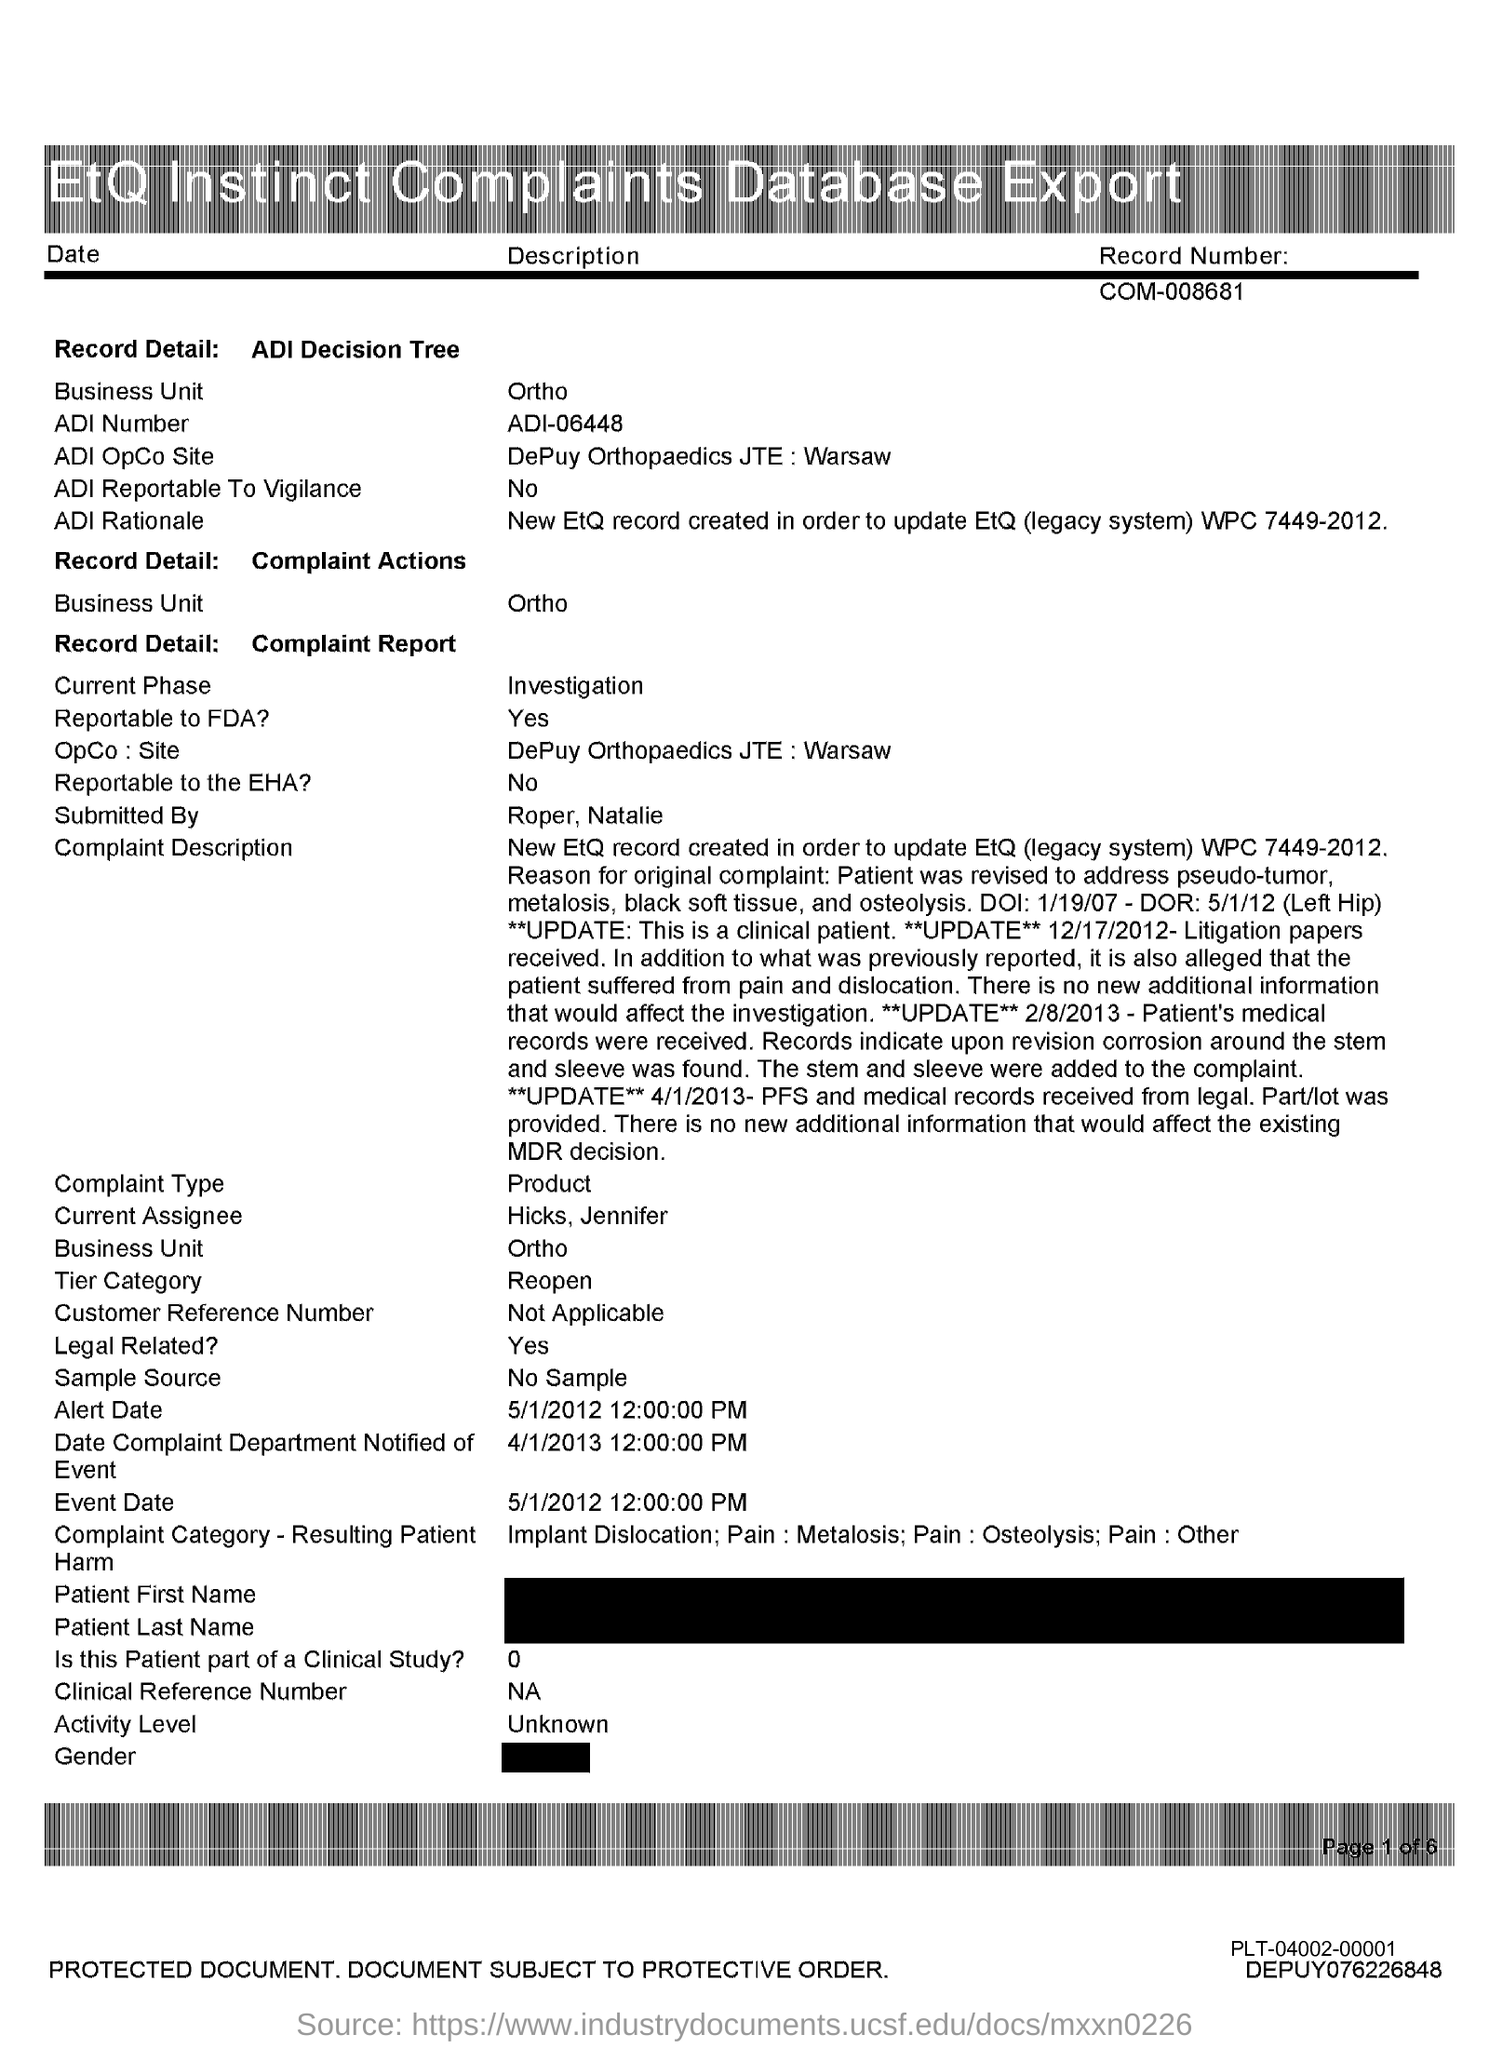Highlight a few significant elements in this photo. The "Site" mentioned in the Complaint report refers to DePuy Orthopaedics JTE:Warsaw. The ADI number in an ADI decision tree refers to a unique identifier assigned to each tree in the database. The ADI number for ADI Decision Tree 06448 is ADI-06448. The ADI OpCo Site in the ADI Decision Tree refers to the location of a manufacturing plant owned by DePuy Orthopaedics in Warsaw, Indiana. The business unit in the table is Ortho. The current phase in the complaint report is investigation. 